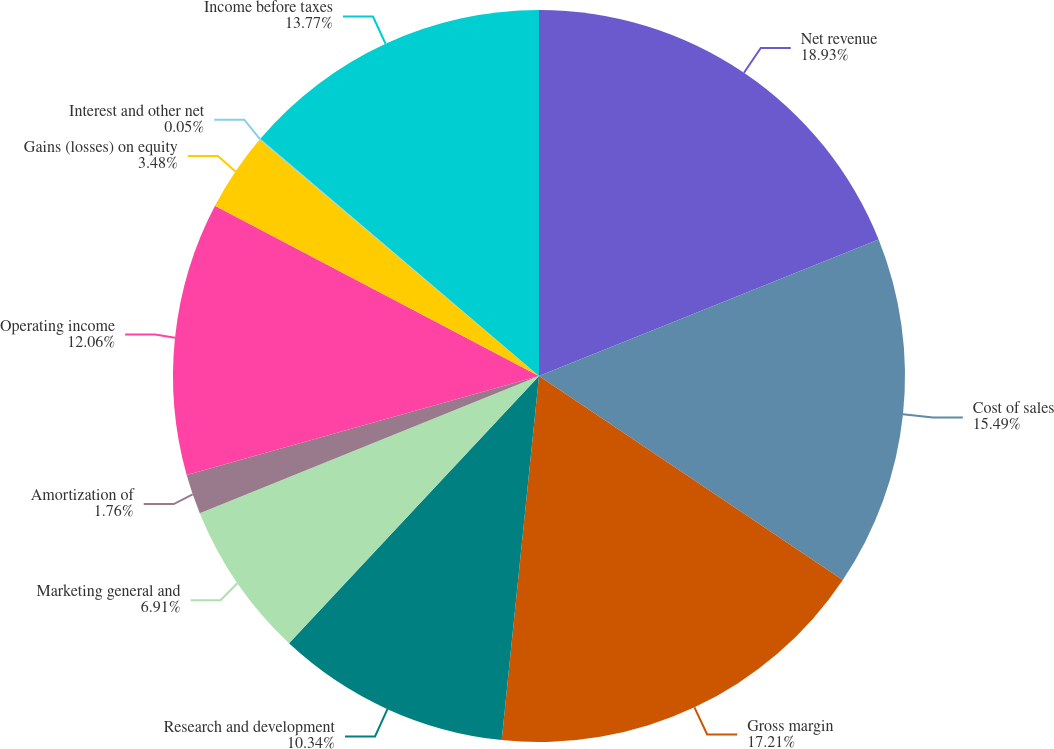<chart> <loc_0><loc_0><loc_500><loc_500><pie_chart><fcel>Net revenue<fcel>Cost of sales<fcel>Gross margin<fcel>Research and development<fcel>Marketing general and<fcel>Amortization of<fcel>Operating income<fcel>Gains (losses) on equity<fcel>Interest and other net<fcel>Income before taxes<nl><fcel>18.92%<fcel>15.49%<fcel>17.21%<fcel>10.34%<fcel>6.91%<fcel>1.76%<fcel>12.06%<fcel>3.48%<fcel>0.05%<fcel>13.77%<nl></chart> 